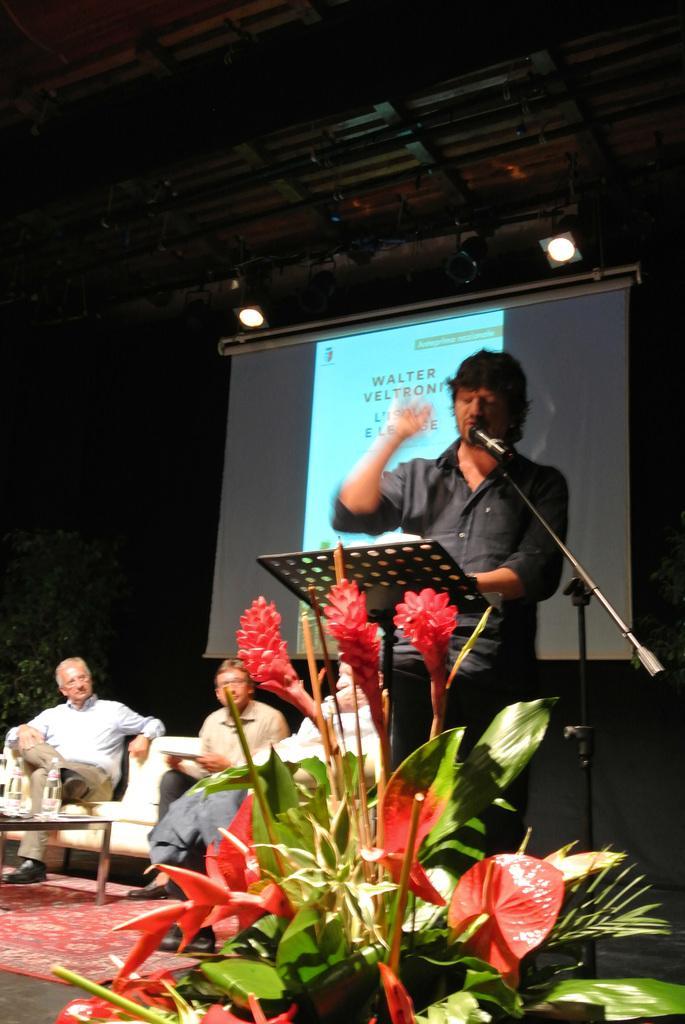Can you describe this image briefly? In this image we can see the person standing and talking into a microphone. And we can see the plant and stand. And at the side there are people sitting on the couch. In front of them there is a table, on the table there are bottles. And at the back there is a screen and at the top there is a ceiling with lights. 